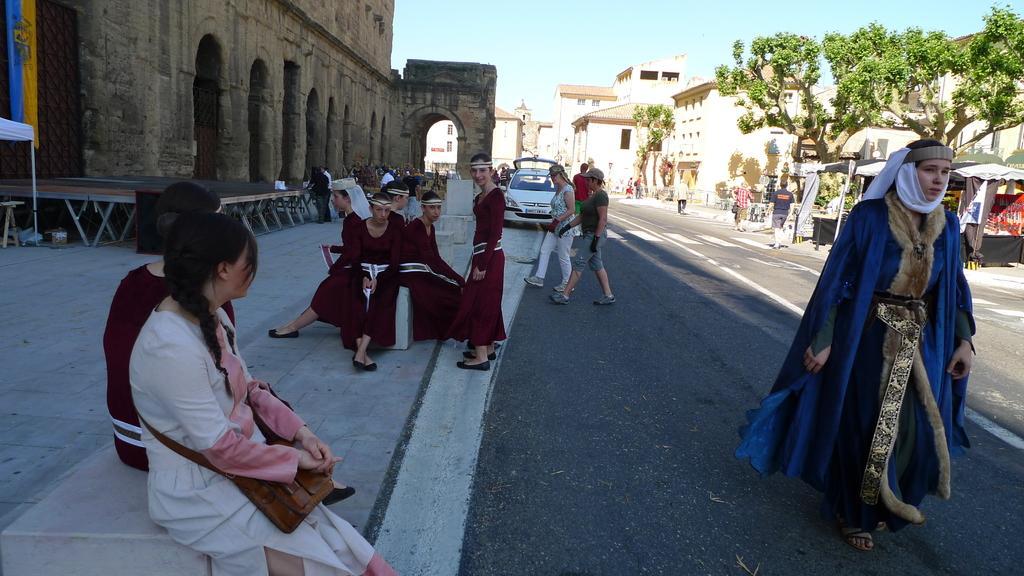Can you describe this image briefly? This is an outside view. On the right side there is a road on which I can see few people are walking. In the background there is a car. Beside the road there are few women sitting. In the background, I can see the buildings and trees. On the top of the image I can see the sky. 